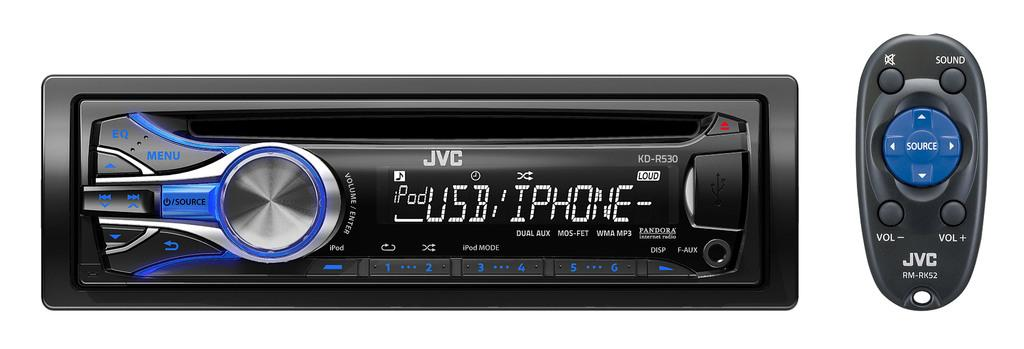<image>
Create a compact narrative representing the image presented. the JVC car radio has a remote with it 